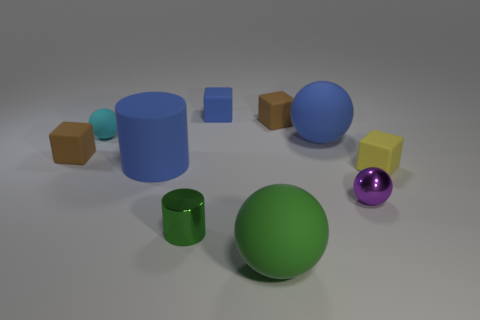Subtract all balls. How many objects are left? 6 Subtract 1 green cylinders. How many objects are left? 9 Subtract all brown matte objects. Subtract all small yellow objects. How many objects are left? 7 Add 3 purple metal balls. How many purple metal balls are left? 4 Add 6 blue objects. How many blue objects exist? 9 